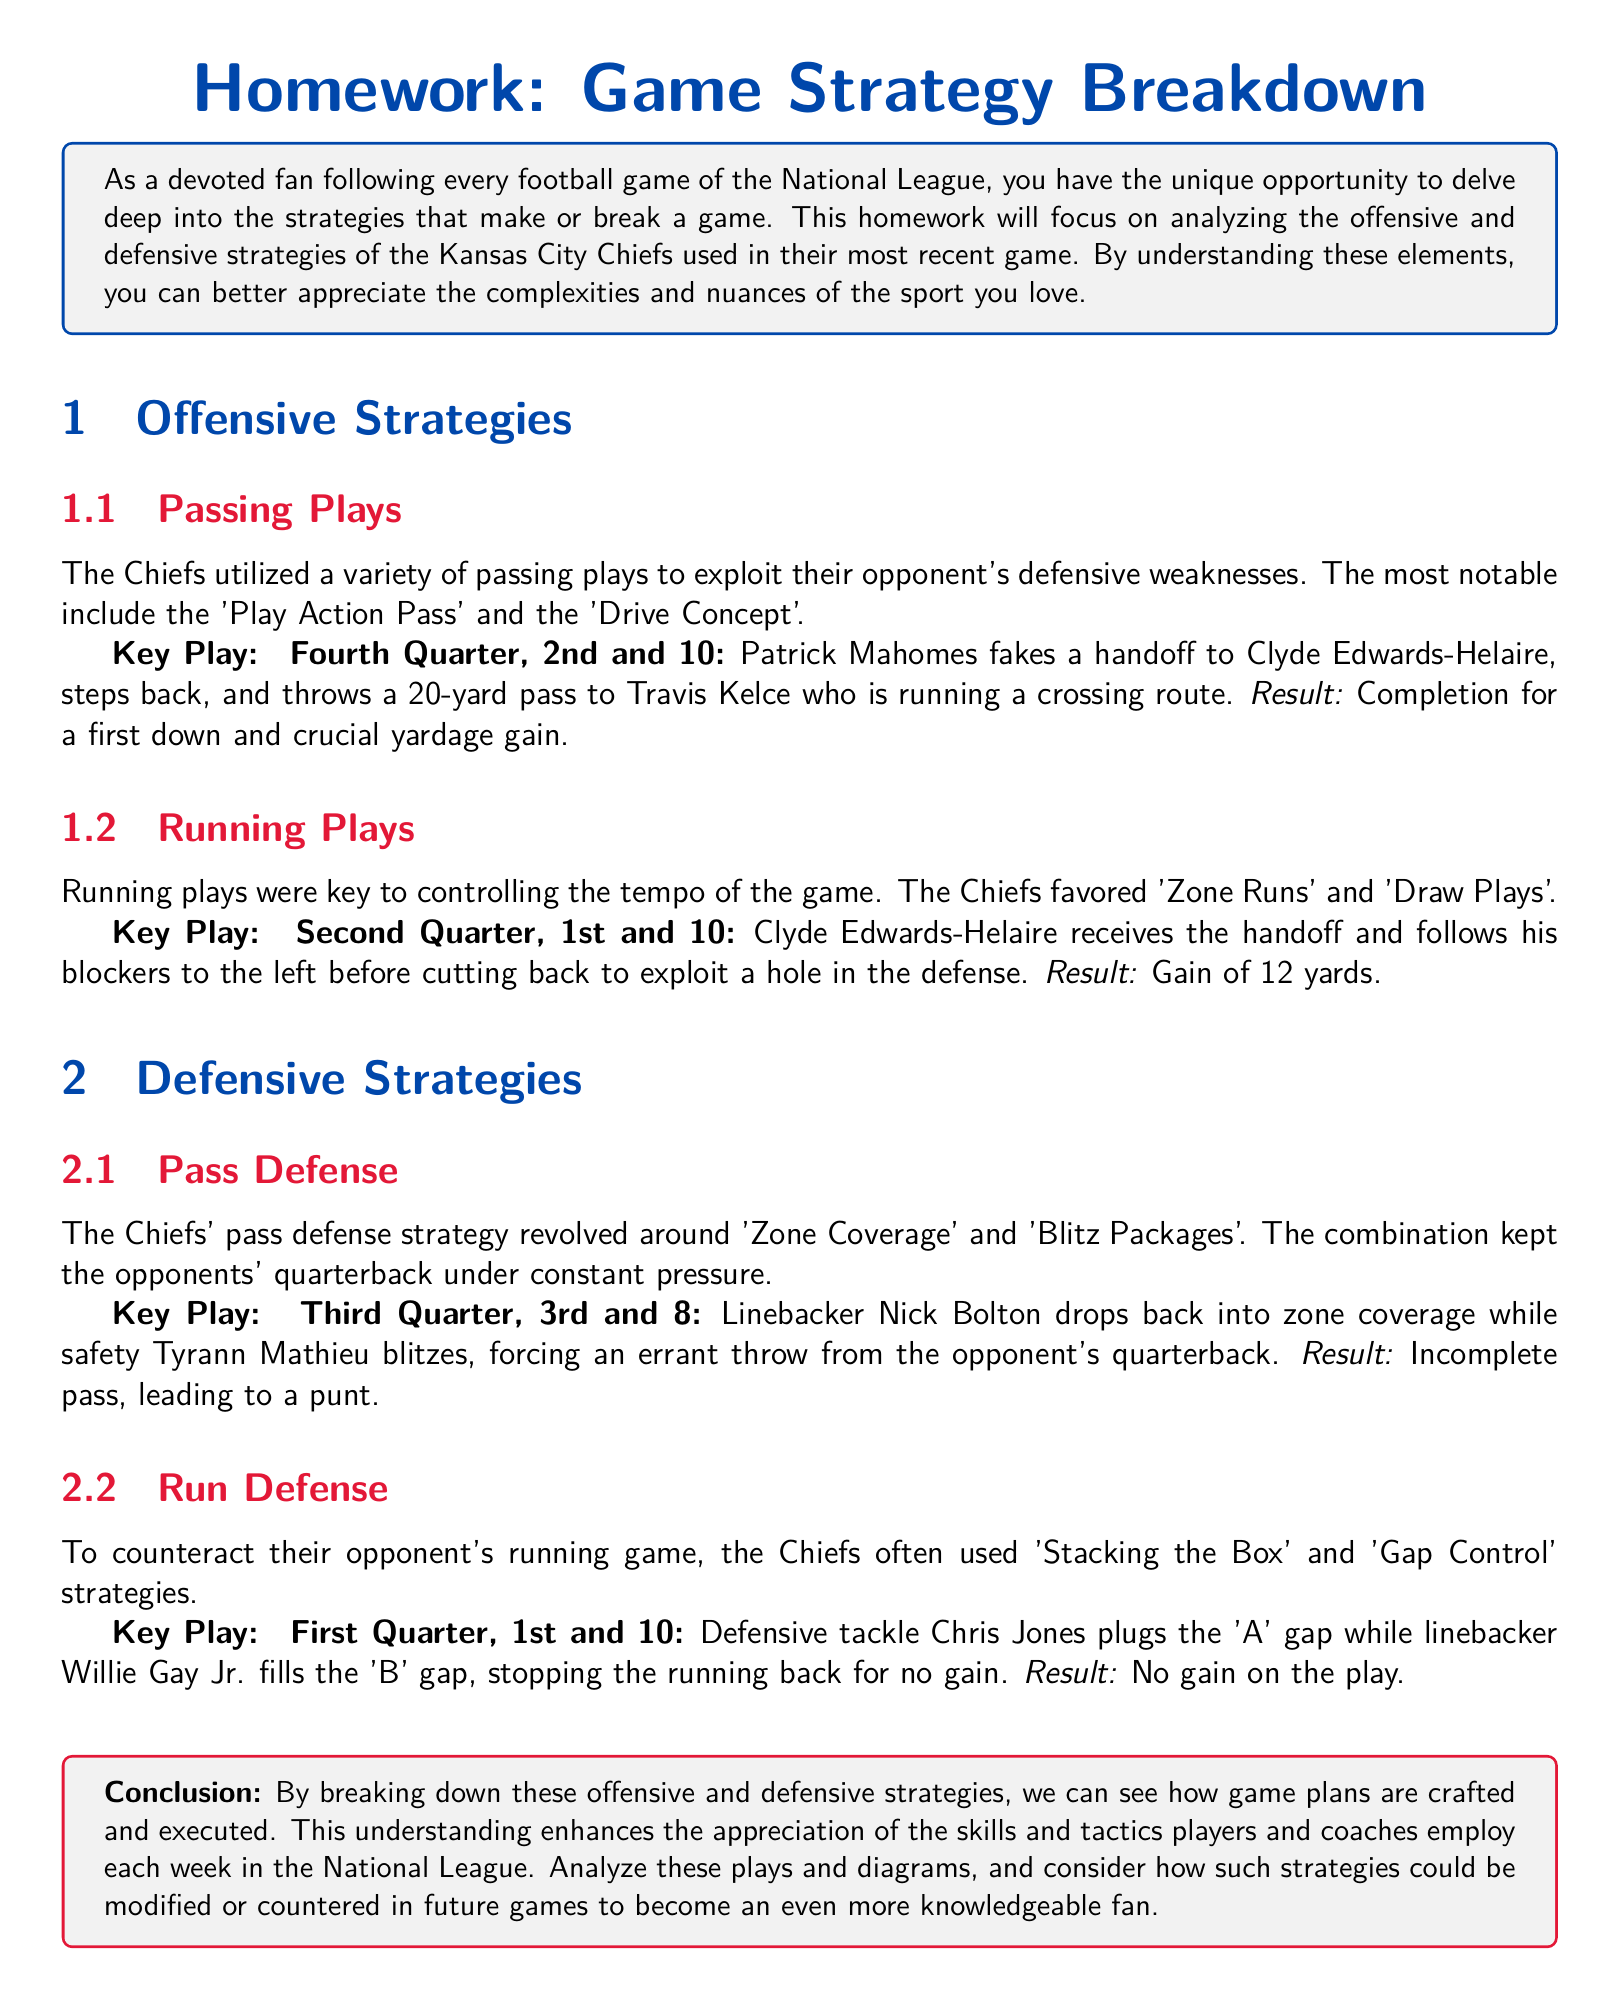What was the name of the team analyzed in the homework? The homework focuses on the offensive and defensive strategies of the Kansas City Chiefs.
Answer: Kansas City Chiefs What was the result of the key play in the fourth quarter? The key play in the fourth quarter resulted in a completion for a first down and crucial yardage gain.
Answer: Completion for a first down Which running play was used to control the tempo of the game? The Chiefs favored 'Zone Runs' and 'Draw Plays' for running plays.
Answer: Zone Runs and Draw Plays What defensive strategy involved pressuring the opponent's quarterback? The Chiefs' pass defense strategy revolved around 'Zone Coverage' and 'Blitz Packages'.
Answer: Zone Coverage and Blitz Packages How many yards did Clyde Edwards-Helaire gain on his key play in the second quarter? The result of the running play with Clyde Edwards-Helaire was a gain of 12 yards.
Answer: 12 yards Which Chiefs player stopped the running back for no gain? Defensive tackle Chris Jones plugged the 'A' gap to stop the running back.
Answer: Chris Jones What is the focus of this homework assignment? The homework assignment is about analyzing the offensive and defensive strategies used by a leading National League team in their most recent game.
Answer: Analyzing strategies In what quarter did Nick Bolton drop back into zone coverage? The key play involving Nick Bolton's zone coverage occurred in the third quarter.
Answer: Third Quarter 